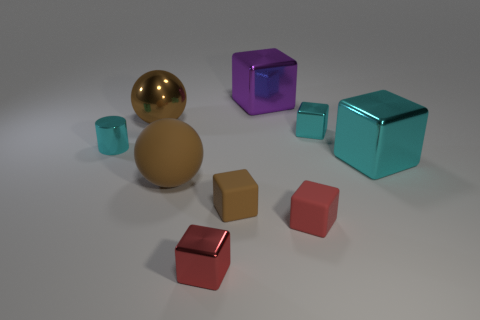Subtract all red cubes. How many cubes are left? 4 Subtract all tiny red cubes. How many cubes are left? 4 Subtract all blue cubes. Subtract all brown spheres. How many cubes are left? 6 Add 1 yellow rubber cylinders. How many objects exist? 10 Subtract all cylinders. How many objects are left? 8 Subtract 0 cyan spheres. How many objects are left? 9 Subtract all tiny cyan metal things. Subtract all blocks. How many objects are left? 1 Add 4 large objects. How many large objects are left? 8 Add 8 blue cubes. How many blue cubes exist? 8 